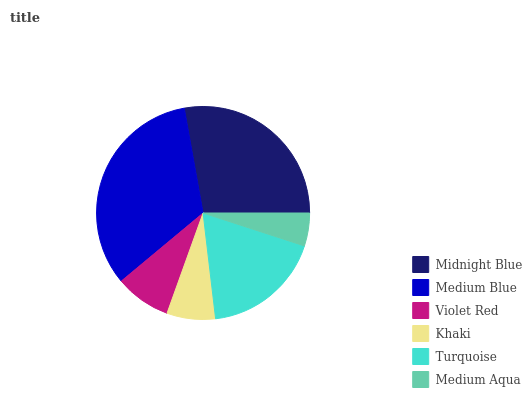Is Medium Aqua the minimum?
Answer yes or no. Yes. Is Medium Blue the maximum?
Answer yes or no. Yes. Is Violet Red the minimum?
Answer yes or no. No. Is Violet Red the maximum?
Answer yes or no. No. Is Medium Blue greater than Violet Red?
Answer yes or no. Yes. Is Violet Red less than Medium Blue?
Answer yes or no. Yes. Is Violet Red greater than Medium Blue?
Answer yes or no. No. Is Medium Blue less than Violet Red?
Answer yes or no. No. Is Turquoise the high median?
Answer yes or no. Yes. Is Violet Red the low median?
Answer yes or no. Yes. Is Khaki the high median?
Answer yes or no. No. Is Medium Blue the low median?
Answer yes or no. No. 